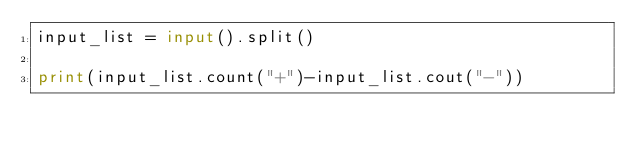<code> <loc_0><loc_0><loc_500><loc_500><_Python_>input_list = input().split()

print(input_list.count("+")-input_list.cout("-"))</code> 